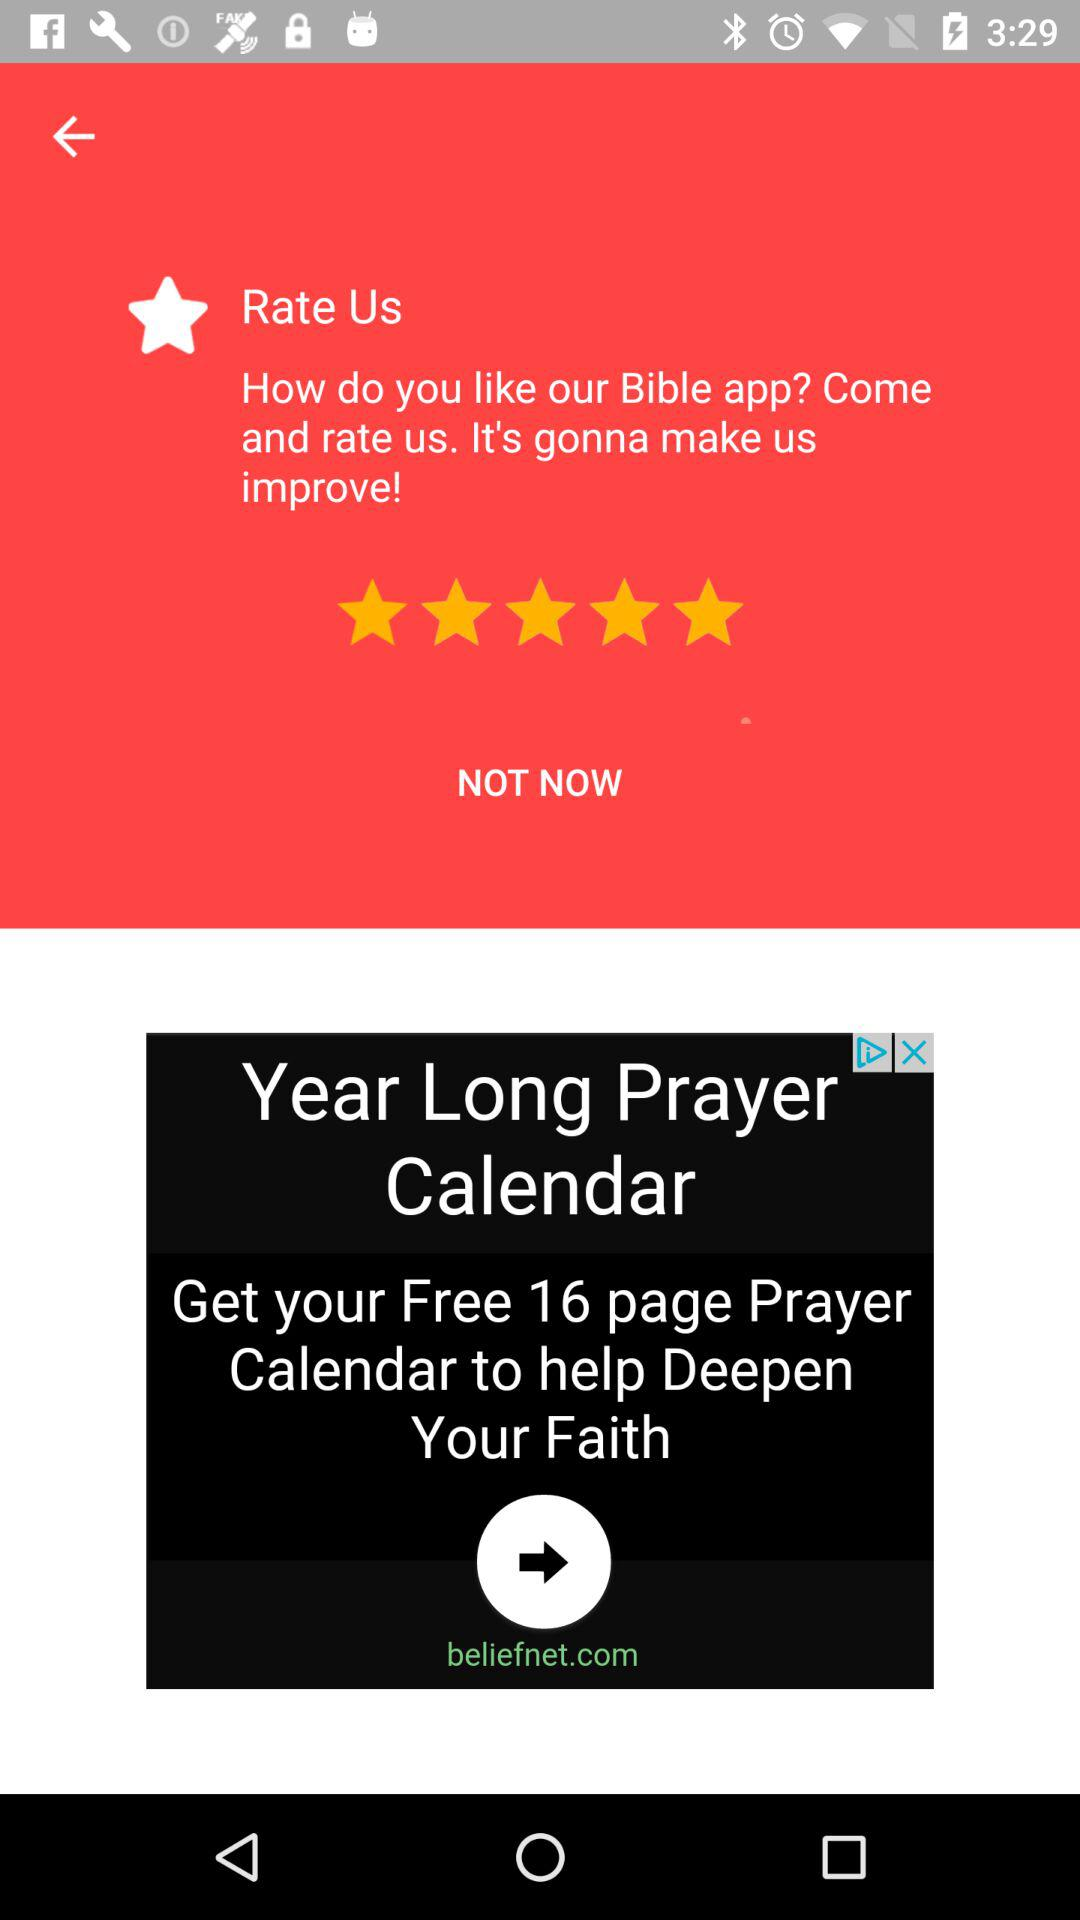What is the rating of the application? The rating of the application is 5 stars. 